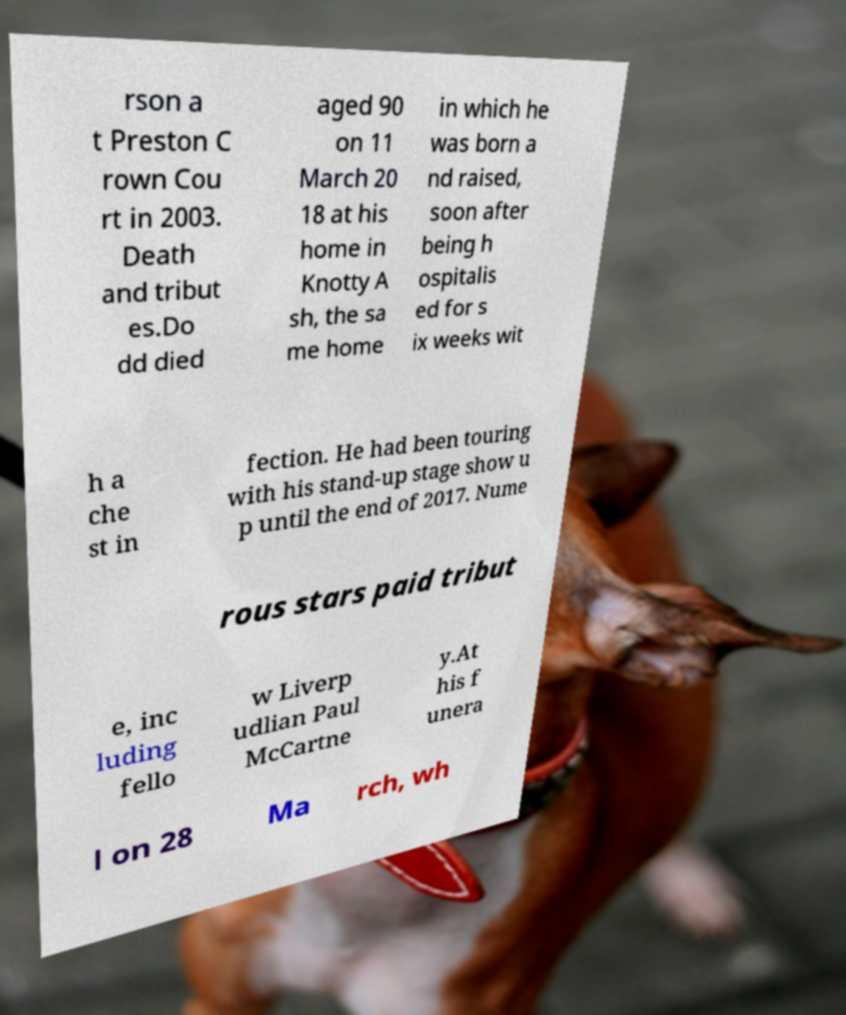Can you read and provide the text displayed in the image?This photo seems to have some interesting text. Can you extract and type it out for me? rson a t Preston C rown Cou rt in 2003. Death and tribut es.Do dd died aged 90 on 11 March 20 18 at his home in Knotty A sh, the sa me home in which he was born a nd raised, soon after being h ospitalis ed for s ix weeks wit h a che st in fection. He had been touring with his stand-up stage show u p until the end of 2017. Nume rous stars paid tribut e, inc luding fello w Liverp udlian Paul McCartne y.At his f unera l on 28 Ma rch, wh 